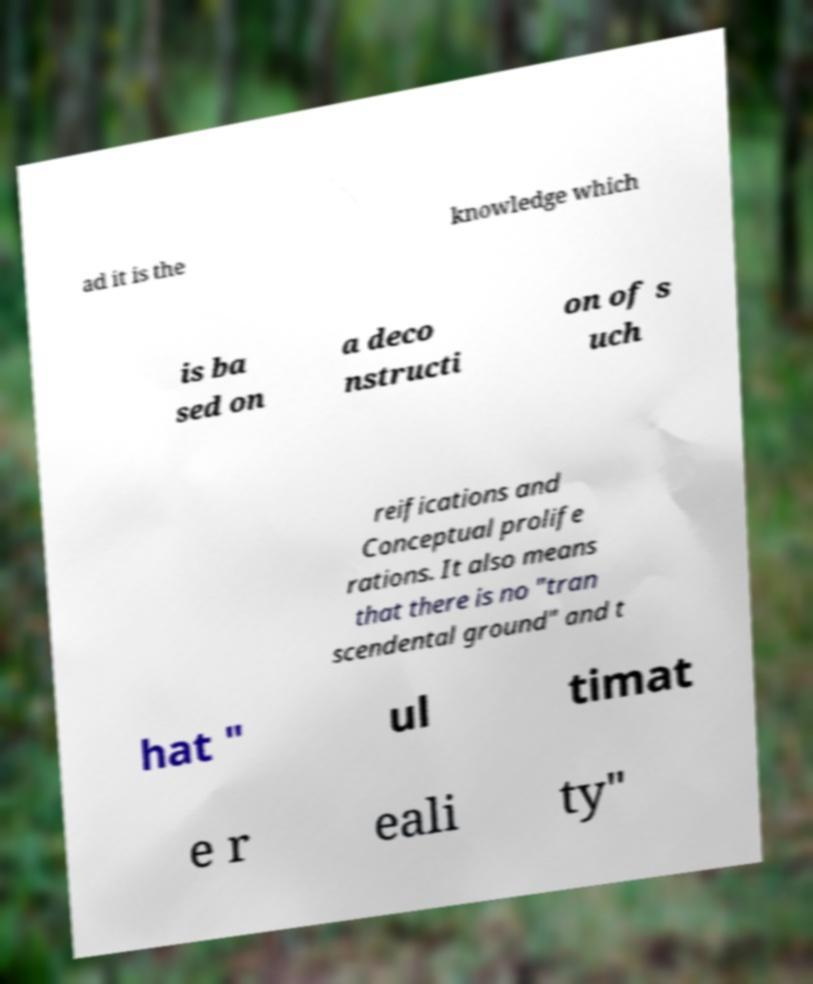Could you extract and type out the text from this image? ad it is the knowledge which is ba sed on a deco nstructi on of s uch reifications and Conceptual prolife rations. It also means that there is no "tran scendental ground" and t hat " ul timat e r eali ty" 